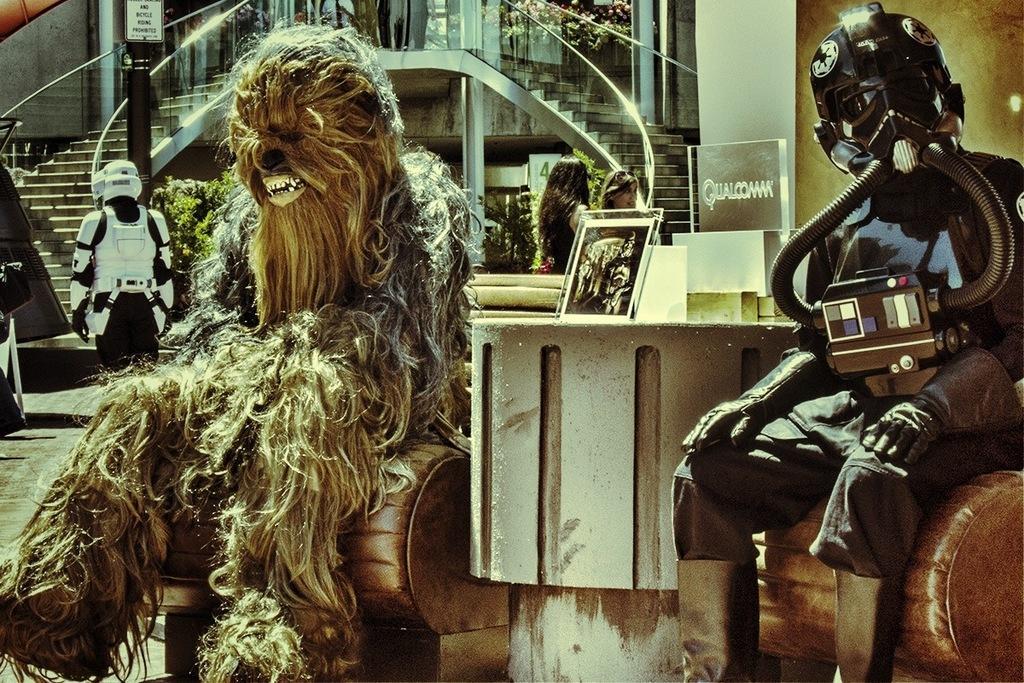Can you describe this image briefly? In this picture I can see a person in an animal costume, there are two robots, there are boards, plants, stairs and there are two persons. 